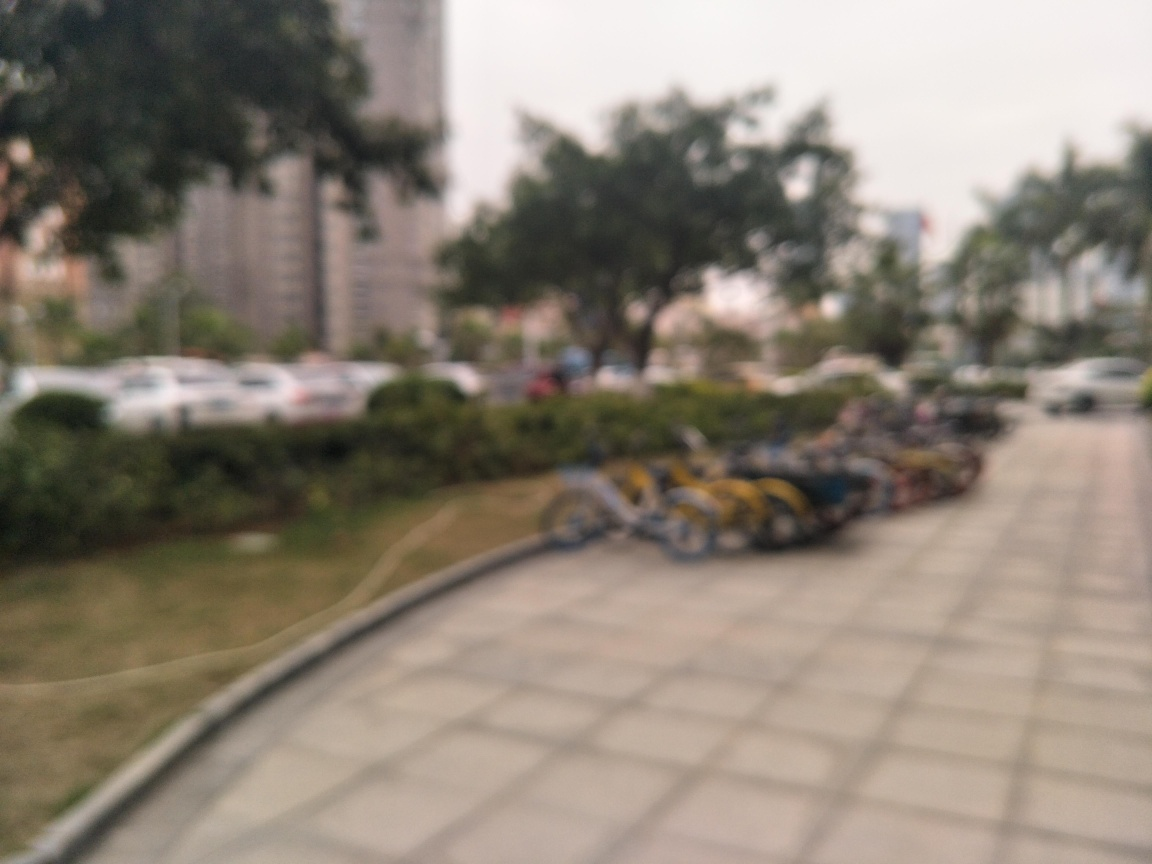Is the background blurred?
 Yes. 